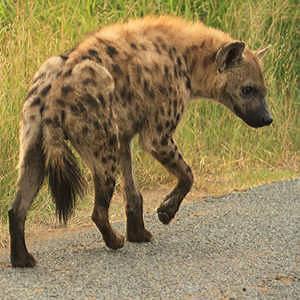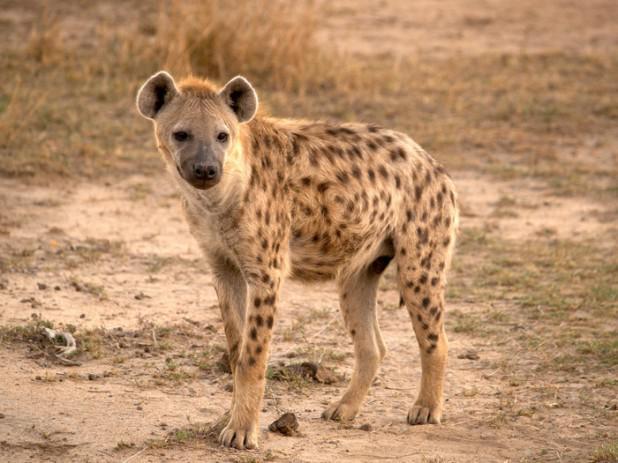The first image is the image on the left, the second image is the image on the right. Assess this claim about the two images: "At least one image shows a single hyena with its mouth partly open showing teeth.". Correct or not? Answer yes or no. No. 